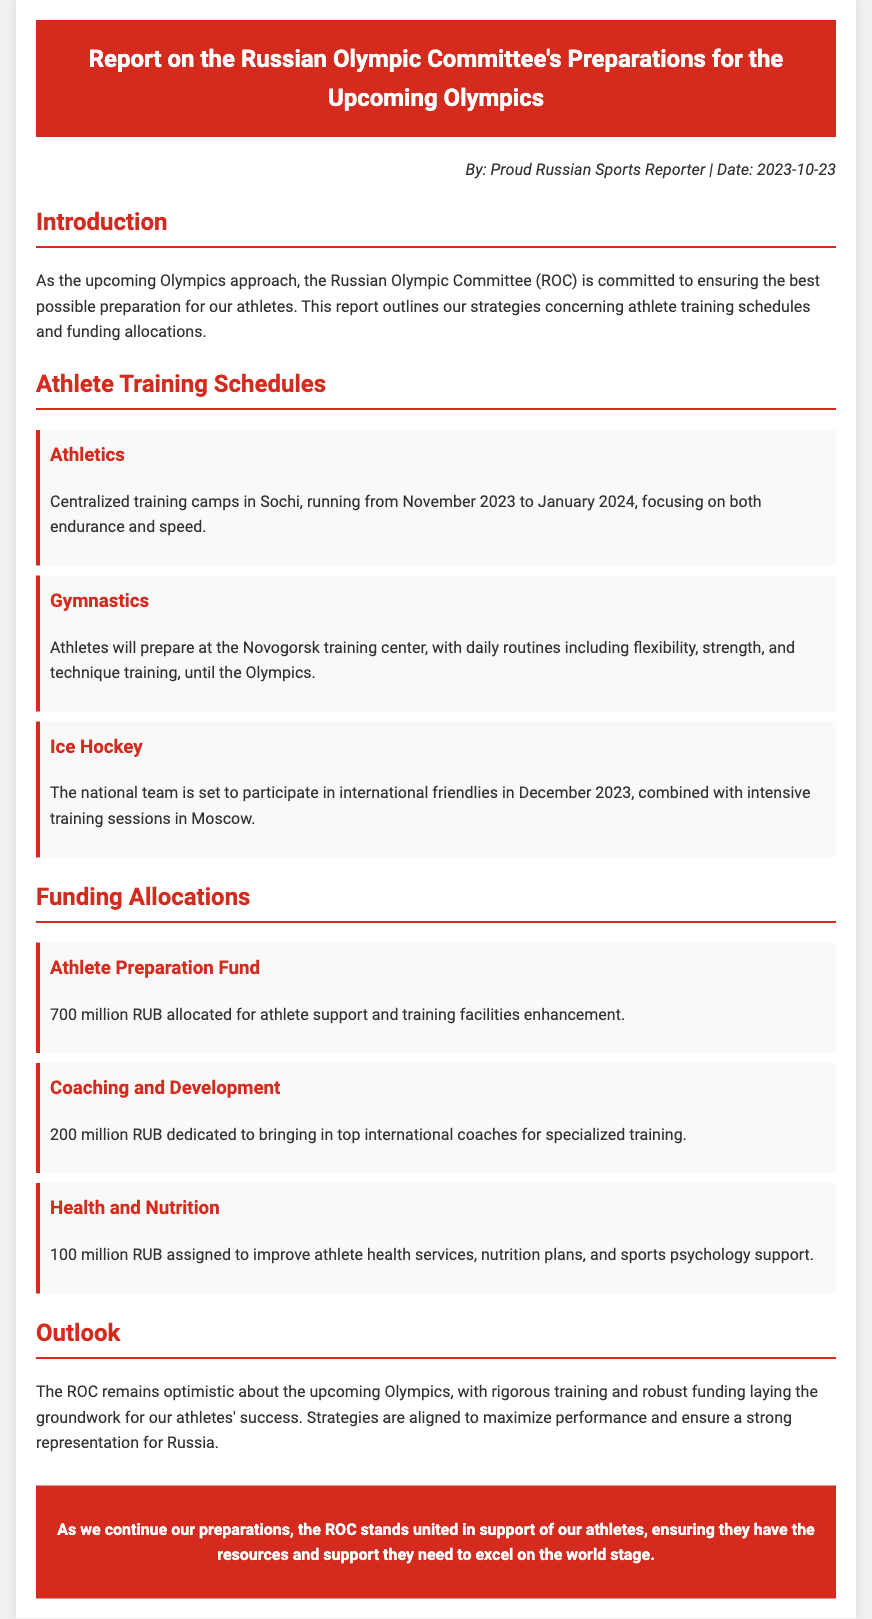What is the main purpose of the report? The report outlines the strategies concerning athlete training schedules and funding allocations for the upcoming Olympics.
Answer: Strategies for athlete training and funding allocations When will the athletics training camps take place? The athletics training camps in Sochi run from November 2023 to January 2024.
Answer: November 2023 to January 2024 How much is allocated to the Athlete Preparation Fund? The document states that 700 million RUB is allocated for athlete support and training facilities enhancement.
Answer: 700 million RUB Which sport uses the Novogorsk training center? The gymnastics athletes will prepare at the Novogorsk training center.
Answer: Gymnastics What type of training will ice hockey athletes participate in December 2023? The national team will participate in international friendlies combined with intensive training sessions.
Answer: International friendlies and intensive training sessions How much funding is dedicated to health and nutrition services? The document states that 100 million RUB is assigned to improve athlete health services, nutrition plans, and sports psychology support.
Answer: 100 million RUB What is the overall outlook of the ROC for the upcoming Olympics? The ROC remains optimistic about the upcoming Olympics, with strategies to maximize performance and ensure strong representation.
Answer: Optimistic Who authored the report? The report is authored by a Proud Russian Sports Reporter.
Answer: Proud Russian Sports Reporter 